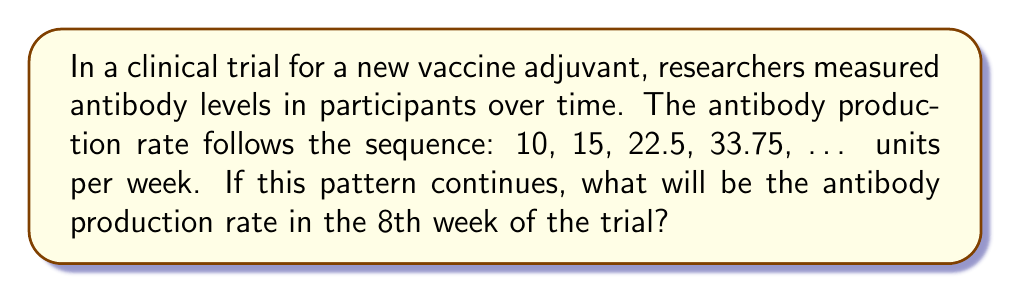Teach me how to tackle this problem. Let's approach this step-by-step:

1) First, we need to identify the pattern in the sequence:
   10 → 15 → 22.5 → 33.75 → ...

2) To find the relationship between consecutive terms, let's divide each term by the previous one:
   $\frac{15}{10} = 1.5$
   $\frac{22.5}{15} = 1.5$
   $\frac{33.75}{22.5} = 1.5$

3) We can see that each term is 1.5 times the previous term. This is a geometric sequence with a common ratio of 1.5.

4) The general formula for a geometric sequence is:
   $a_n = a_1 \cdot r^{n-1}$
   Where $a_n$ is the nth term, $a_1$ is the first term, r is the common ratio, and n is the position of the term.

5) In this case:
   $a_1 = 10$ (first term)
   $r = 1.5$ (common ratio)
   We need to find $a_8$ (8th term)

6) Plugging into the formula:
   $a_8 = 10 \cdot 1.5^{8-1} = 10 \cdot 1.5^7$

7) Calculate:
   $a_8 = 10 \cdot 1.5^7 = 10 \cdot 17.0859375 = 170.859375$

Therefore, the antibody production rate in the 8th week will be approximately 170.86 units per week.
Answer: 170.86 units/week 